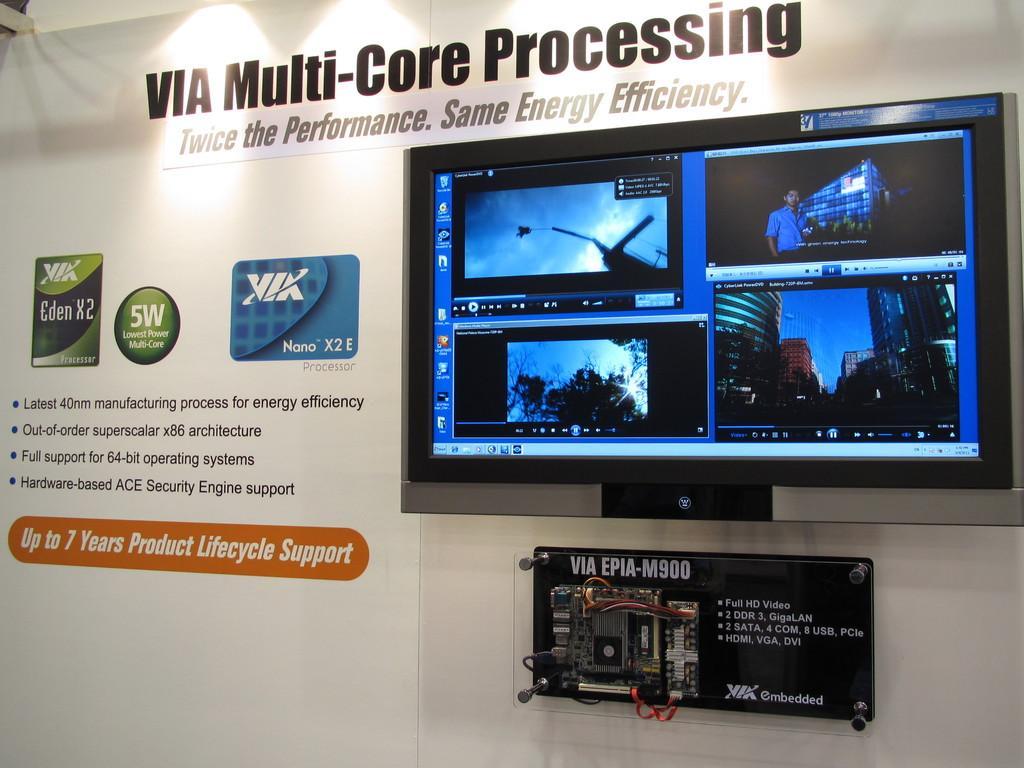Describe this image in one or two sentences. In this image there is a tv screen on the wall. There is another object. There is some text. 